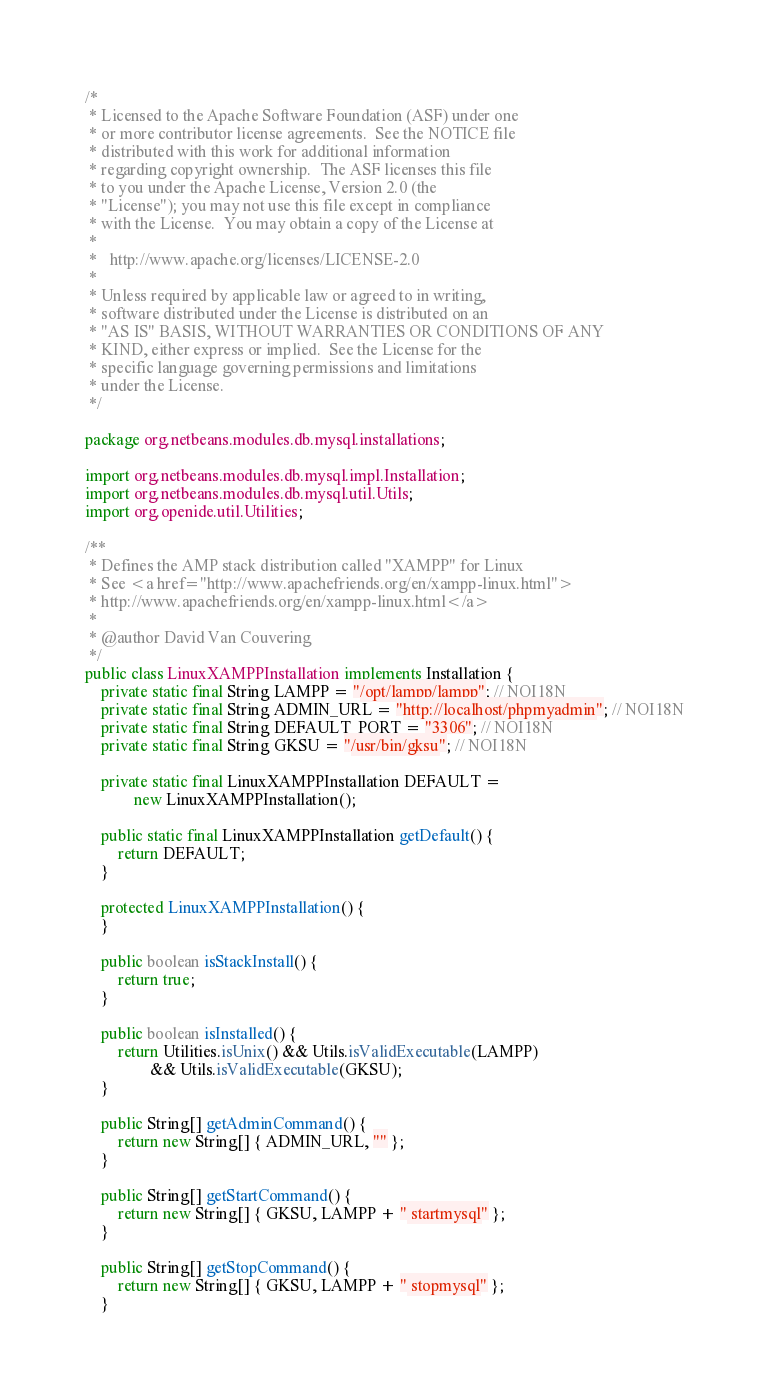<code> <loc_0><loc_0><loc_500><loc_500><_Java_>/*
 * Licensed to the Apache Software Foundation (ASF) under one
 * or more contributor license agreements.  See the NOTICE file
 * distributed with this work for additional information
 * regarding copyright ownership.  The ASF licenses this file
 * to you under the Apache License, Version 2.0 (the
 * "License"); you may not use this file except in compliance
 * with the License.  You may obtain a copy of the License at
 *
 *   http://www.apache.org/licenses/LICENSE-2.0
 *
 * Unless required by applicable law or agreed to in writing,
 * software distributed under the License is distributed on an
 * "AS IS" BASIS, WITHOUT WARRANTIES OR CONDITIONS OF ANY
 * KIND, either express or implied.  See the License for the
 * specific language governing permissions and limitations
 * under the License.
 */

package org.netbeans.modules.db.mysql.installations;

import org.netbeans.modules.db.mysql.impl.Installation;
import org.netbeans.modules.db.mysql.util.Utils;
import org.openide.util.Utilities;

/**
 * Defines the AMP stack distribution called "XAMPP" for Linux
 * See <a href="http://www.apachefriends.org/en/xampp-linux.html">
 * http://www.apachefriends.org/en/xampp-linux.html</a>
 * 
 * @author David Van Couvering
 */
public class LinuxXAMPPInstallation implements Installation {
    private static final String LAMPP = "/opt/lampp/lampp"; // NOI18N
    private static final String ADMIN_URL = "http://localhost/phpmyadmin"; // NOI18N
    private static final String DEFAULT_PORT = "3306"; // NOI18N
    private static final String GKSU = "/usr/bin/gksu"; // NOI18N
        
    private static final LinuxXAMPPInstallation DEFAULT = 
            new LinuxXAMPPInstallation();
    
    public static final LinuxXAMPPInstallation getDefault() {
        return DEFAULT;
    }
    
    protected LinuxXAMPPInstallation() {
    }

    public boolean isStackInstall() {
        return true;
    }

    public boolean isInstalled() {
        return Utilities.isUnix() && Utils.isValidExecutable(LAMPP)
                && Utils.isValidExecutable(GKSU);
    }

    public String[] getAdminCommand() {
        return new String[] { ADMIN_URL, "" };
    }

    public String[] getStartCommand() {
        return new String[] { GKSU, LAMPP + " startmysql" };
    }

    public String[] getStopCommand() {
        return new String[] { GKSU, LAMPP + " stopmysql" };
    }</code> 